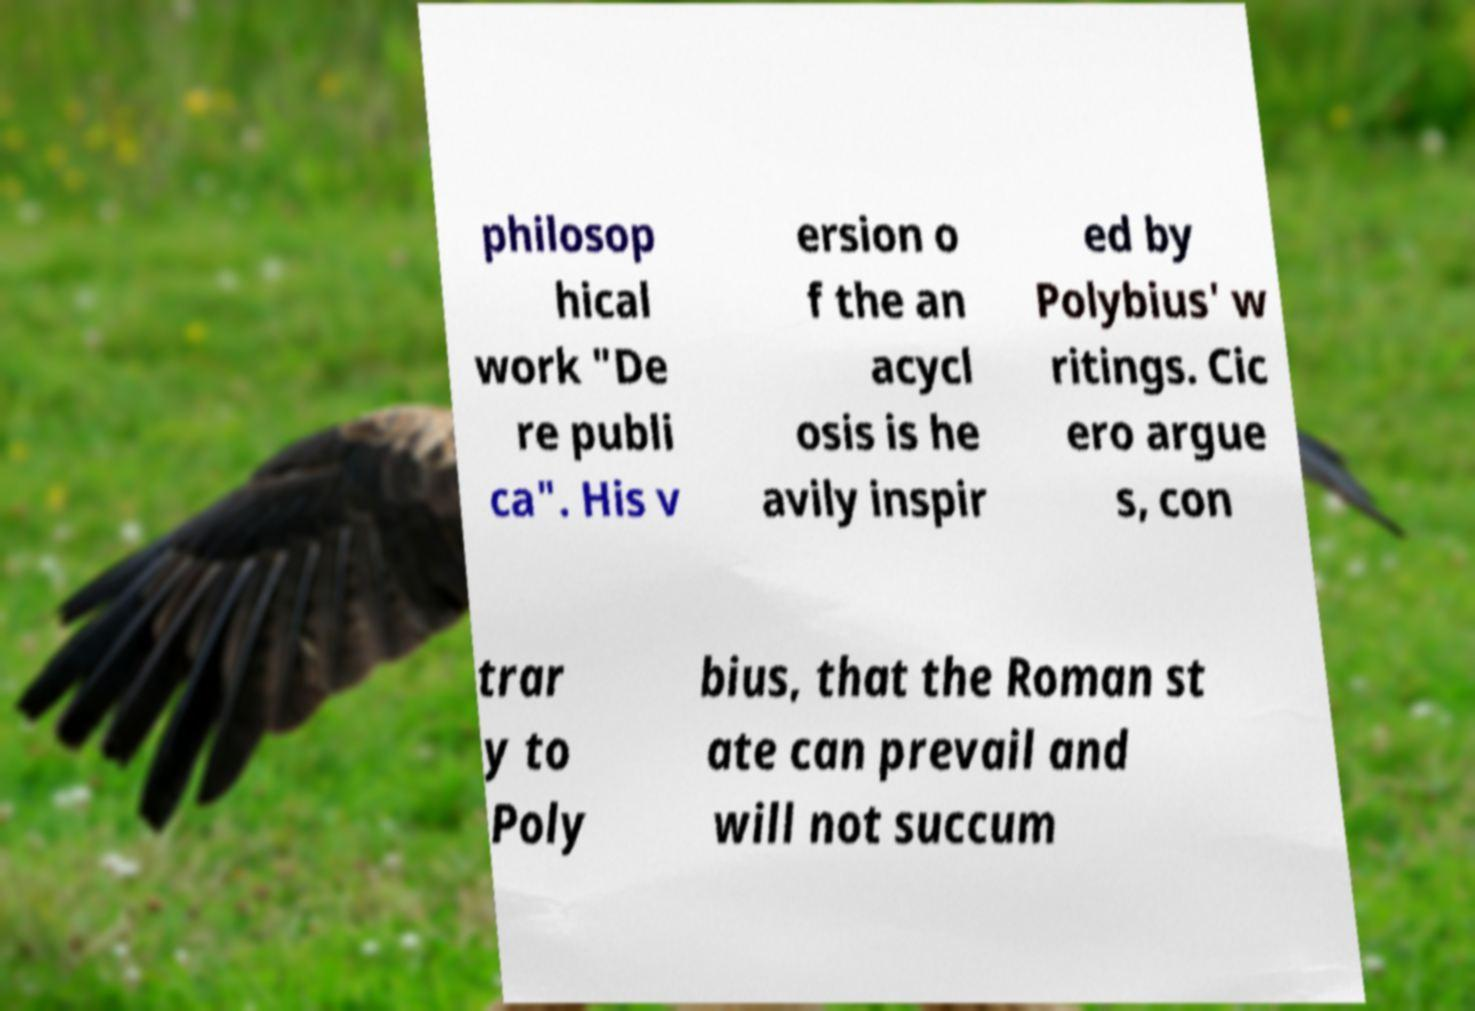Please read and relay the text visible in this image. What does it say? philosop hical work "De re publi ca". His v ersion o f the an acycl osis is he avily inspir ed by Polybius' w ritings. Cic ero argue s, con trar y to Poly bius, that the Roman st ate can prevail and will not succum 